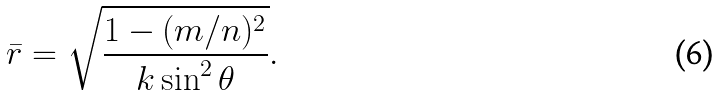Convert formula to latex. <formula><loc_0><loc_0><loc_500><loc_500>\bar { r } = \sqrt { \frac { 1 - ( m / n ) ^ { 2 } } { k \sin ^ { 2 } \theta } } .</formula> 